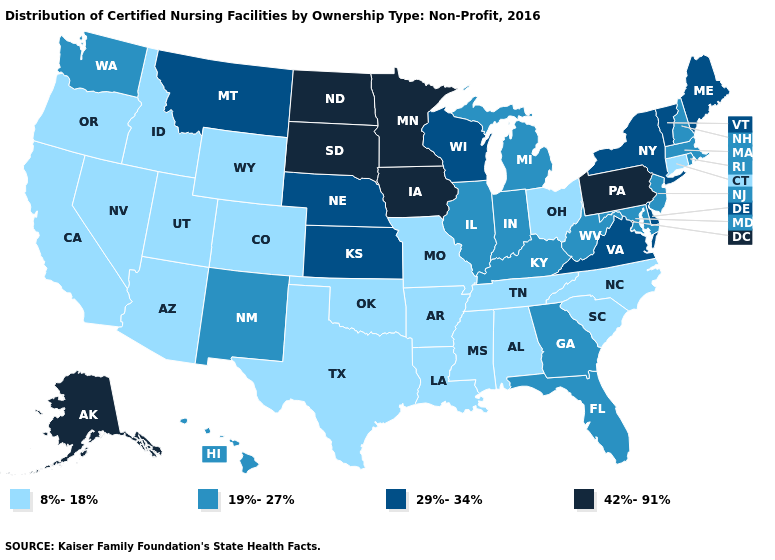Which states have the lowest value in the USA?
Be succinct. Alabama, Arizona, Arkansas, California, Colorado, Connecticut, Idaho, Louisiana, Mississippi, Missouri, Nevada, North Carolina, Ohio, Oklahoma, Oregon, South Carolina, Tennessee, Texas, Utah, Wyoming. Is the legend a continuous bar?
Concise answer only. No. Does Utah have the same value as New Mexico?
Answer briefly. No. Name the states that have a value in the range 42%-91%?
Give a very brief answer. Alaska, Iowa, Minnesota, North Dakota, Pennsylvania, South Dakota. What is the highest value in the South ?
Write a very short answer. 29%-34%. What is the value of Arkansas?
Answer briefly. 8%-18%. Name the states that have a value in the range 8%-18%?
Write a very short answer. Alabama, Arizona, Arkansas, California, Colorado, Connecticut, Idaho, Louisiana, Mississippi, Missouri, Nevada, North Carolina, Ohio, Oklahoma, Oregon, South Carolina, Tennessee, Texas, Utah, Wyoming. Name the states that have a value in the range 42%-91%?
Concise answer only. Alaska, Iowa, Minnesota, North Dakota, Pennsylvania, South Dakota. Which states have the lowest value in the USA?
Keep it brief. Alabama, Arizona, Arkansas, California, Colorado, Connecticut, Idaho, Louisiana, Mississippi, Missouri, Nevada, North Carolina, Ohio, Oklahoma, Oregon, South Carolina, Tennessee, Texas, Utah, Wyoming. Does the map have missing data?
Short answer required. No. Does the map have missing data?
Concise answer only. No. Name the states that have a value in the range 29%-34%?
Concise answer only. Delaware, Kansas, Maine, Montana, Nebraska, New York, Vermont, Virginia, Wisconsin. Name the states that have a value in the range 29%-34%?
Answer briefly. Delaware, Kansas, Maine, Montana, Nebraska, New York, Vermont, Virginia, Wisconsin. 